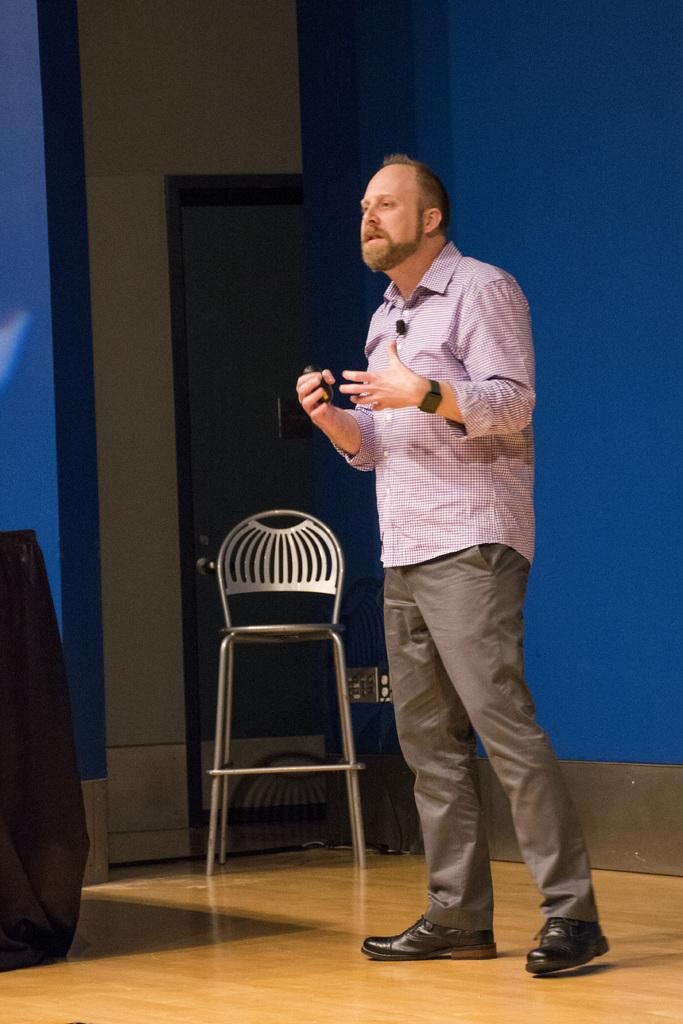Who is present in the image? There is a man in the image. Where is the man located in the image? The man is standing on the right side of the image. What piece of furniture can be seen in the image? There is a chair in the image. Where is the chair located in the image? The chair is in the center of the image. What architectural feature is present in the image? There is a door in the image. Where is the door located in the image? The door is in the center of the image. What type of mitten is the man wearing in the image? The man is not wearing a mitten in the image; he is not wearing any gloves or mittens. How does the man access his bank account in the image? There is no mention of a bank account or any financial transactions in the image. 